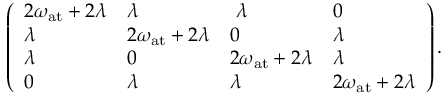<formula> <loc_0><loc_0><loc_500><loc_500>\left ( \begin{array} { l l l l } { 2 \omega _ { a t } + 2 \lambda } & { \lambda } & { \lambda } & { 0 } \\ { \lambda } & { 2 \omega _ { a t } + 2 \lambda } & { 0 } & { \lambda } \\ { \lambda } & { 0 } & { 2 \omega _ { a t } + 2 \lambda } & { \lambda } \\ { 0 } & { \lambda } & { \lambda } & { 2 \omega _ { a t } + 2 \lambda } \end{array} \right ) .</formula> 